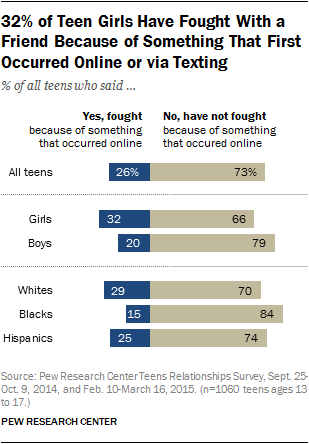Outline some significant characteristics in this image. Thirty-two percent of the girls said 'yes, I fought.' The sum of the difference between "yes, fought" and "No, have not fought" between whites and blacks is 28. 